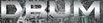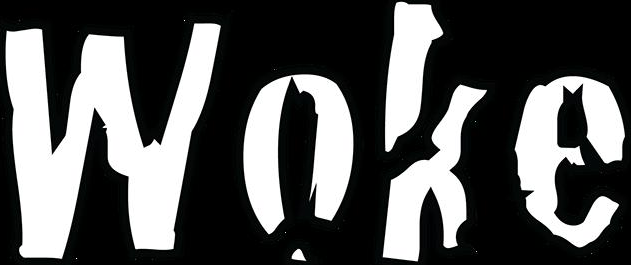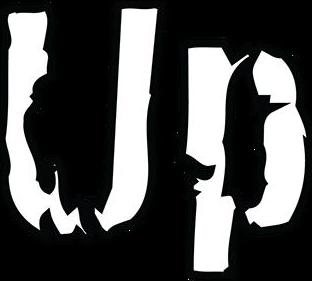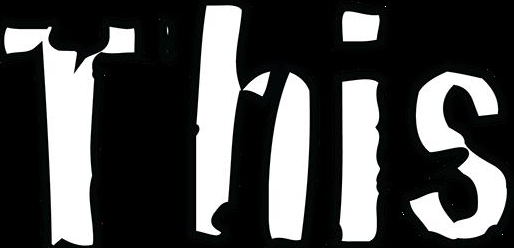What words can you see in these images in sequence, separated by a semicolon? DRUM; Woke; Up; This 